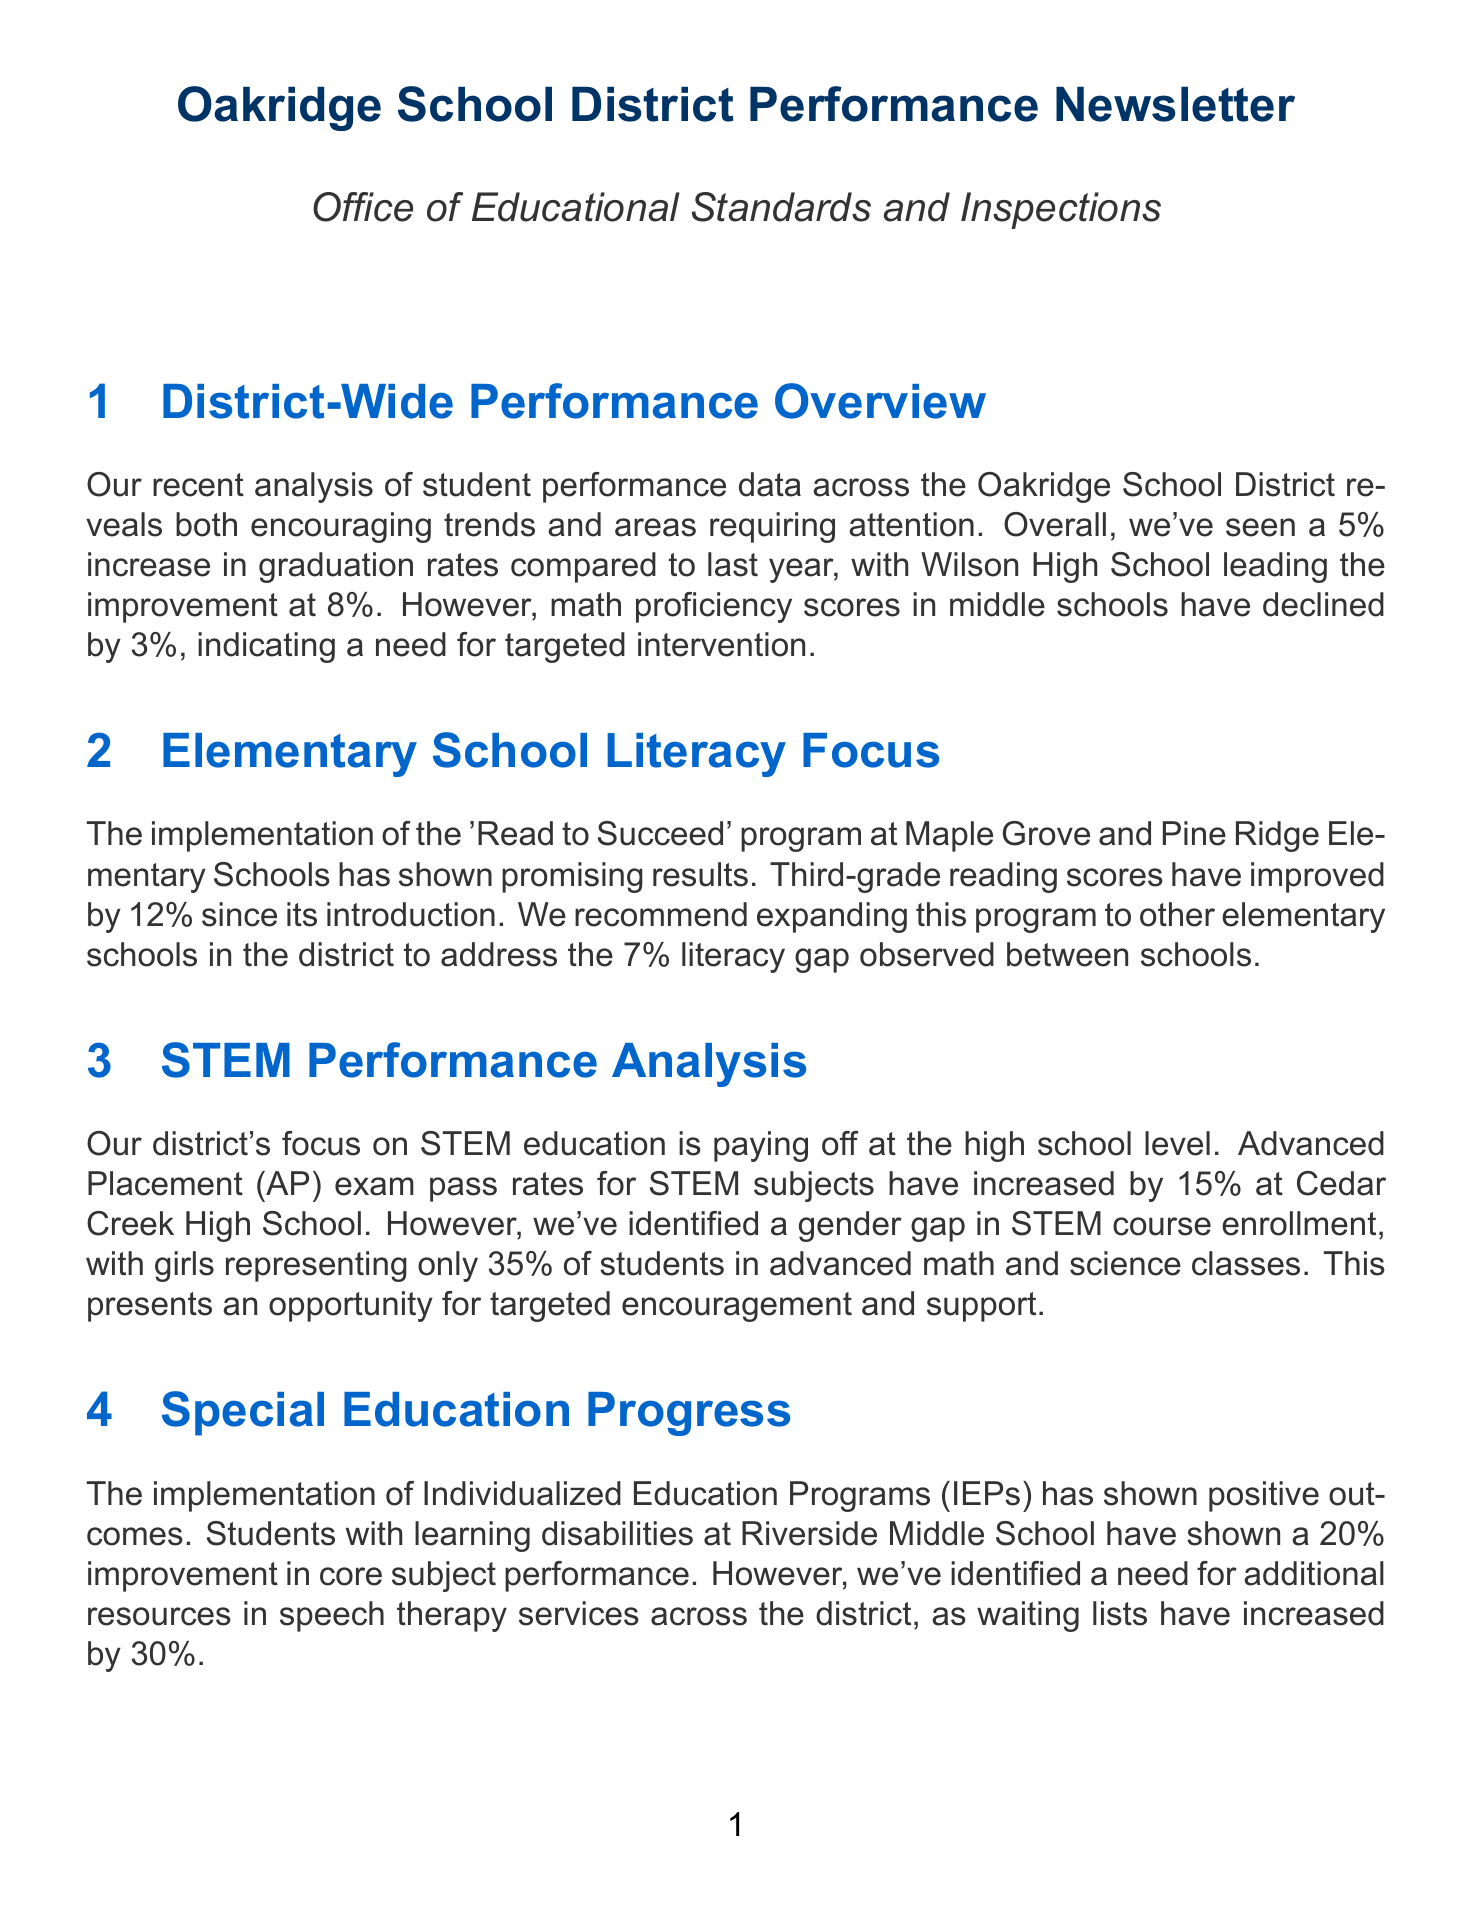What was the increase in graduation rates? The document states a 5% increase in graduation rates compared to last year.
Answer: 5% Which high school had the highest graduation improvement? It mentions that Wilson High School led the improvement with an 8% increase.
Answer: Wilson High School What program showed a 12% improvement in third-grade reading scores? The 'Read to Succeed' program at Maple Grove and Pine Ridge Elementary Schools is highlighted for this improvement.
Answer: 'Read to Succeed' What percentage of girls are enrolled in advanced STEM courses? The document indicates that girls represent only 35% of the students in advanced math and science classes.
Answer: 35% What specific need was identified related to speech therapy? It mentions a 30% increase in waiting lists for speech therapy services across the district.
Answer: Additional resources What is the trend in SAT scores regarding a specific subject? There was a slight 2% increase in English Language Arts (ELA) scores mentioned in the document.
Answer: 2% Which middle school has increasing rates of chronic absenteeism? Sunnyside Middle School is specifically noted for an 8% increase in absenteeism rates.
Answer: Sunnyside Middle School What action item relates to expanding a literacy program? The action item involves developing a plan to expand the 'Read to Succeed' program to all elementary schools.
Answer: Expand 'Read to Succeed' What is the gender gap issue identified in STEM? The document highlights the gender gap in enrollment in advanced STEM courses specifically regarding girls' representation.
Answer: Gender gap in enrollment 